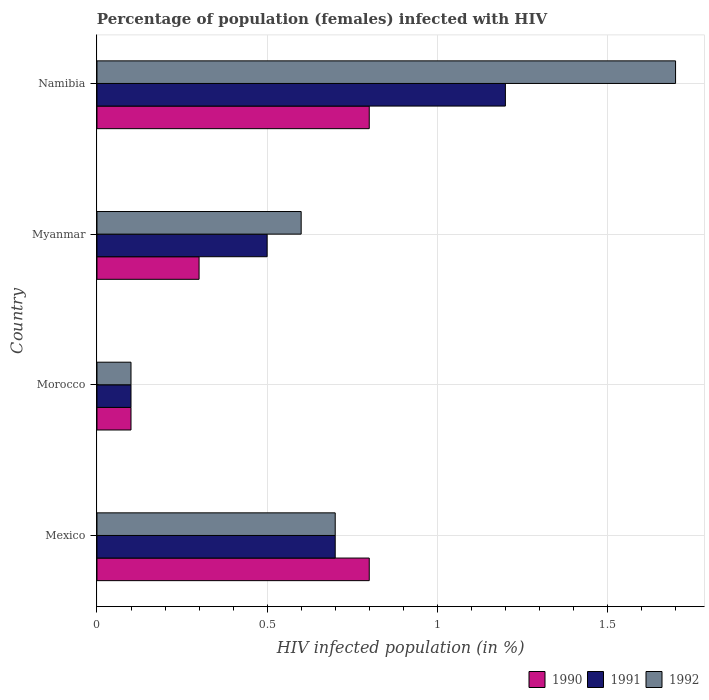Are the number of bars per tick equal to the number of legend labels?
Your answer should be very brief. Yes. What is the label of the 2nd group of bars from the top?
Offer a very short reply. Myanmar. What is the percentage of HIV infected female population in 1992 in Mexico?
Offer a terse response. 0.7. Across all countries, what is the maximum percentage of HIV infected female population in 1992?
Offer a terse response. 1.7. In which country was the percentage of HIV infected female population in 1991 maximum?
Your answer should be compact. Namibia. In which country was the percentage of HIV infected female population in 1991 minimum?
Ensure brevity in your answer.  Morocco. What is the difference between the percentage of HIV infected female population in 1992 in Myanmar and the percentage of HIV infected female population in 1991 in Namibia?
Offer a terse response. -0.6. What is the average percentage of HIV infected female population in 1992 per country?
Provide a succinct answer. 0.77. What is the ratio of the percentage of HIV infected female population in 1990 in Myanmar to that in Namibia?
Your answer should be very brief. 0.37. What is the difference between the highest and the lowest percentage of HIV infected female population in 1990?
Offer a terse response. 0.7. What does the 2nd bar from the bottom in Morocco represents?
Your answer should be compact. 1991. How many countries are there in the graph?
Your answer should be very brief. 4. Does the graph contain grids?
Give a very brief answer. Yes. What is the title of the graph?
Your response must be concise. Percentage of population (females) infected with HIV. Does "2010" appear as one of the legend labels in the graph?
Make the answer very short. No. What is the label or title of the X-axis?
Offer a terse response. HIV infected population (in %). What is the label or title of the Y-axis?
Your answer should be compact. Country. What is the HIV infected population (in %) in 1990 in Mexico?
Give a very brief answer. 0.8. What is the HIV infected population (in %) of 1991 in Mexico?
Make the answer very short. 0.7. What is the HIV infected population (in %) in 1990 in Morocco?
Ensure brevity in your answer.  0.1. What is the HIV infected population (in %) of 1992 in Myanmar?
Ensure brevity in your answer.  0.6. What is the HIV infected population (in %) in 1990 in Namibia?
Your answer should be compact. 0.8. What is the HIV infected population (in %) in 1991 in Namibia?
Offer a very short reply. 1.2. Across all countries, what is the maximum HIV infected population (in %) of 1992?
Offer a very short reply. 1.7. Across all countries, what is the minimum HIV infected population (in %) of 1990?
Ensure brevity in your answer.  0.1. Across all countries, what is the minimum HIV infected population (in %) in 1992?
Ensure brevity in your answer.  0.1. What is the total HIV infected population (in %) in 1990 in the graph?
Provide a succinct answer. 2. What is the total HIV infected population (in %) of 1991 in the graph?
Ensure brevity in your answer.  2.5. What is the total HIV infected population (in %) in 1992 in the graph?
Your response must be concise. 3.1. What is the difference between the HIV infected population (in %) of 1990 in Mexico and that in Morocco?
Keep it short and to the point. 0.7. What is the difference between the HIV infected population (in %) of 1990 in Mexico and that in Myanmar?
Your response must be concise. 0.5. What is the difference between the HIV infected population (in %) in 1991 in Mexico and that in Myanmar?
Ensure brevity in your answer.  0.2. What is the difference between the HIV infected population (in %) of 1992 in Mexico and that in Myanmar?
Your answer should be very brief. 0.1. What is the difference between the HIV infected population (in %) in 1991 in Mexico and that in Namibia?
Your answer should be compact. -0.5. What is the difference between the HIV infected population (in %) of 1992 in Morocco and that in Myanmar?
Your answer should be compact. -0.5. What is the difference between the HIV infected population (in %) in 1990 in Morocco and that in Namibia?
Offer a terse response. -0.7. What is the difference between the HIV infected population (in %) in 1990 in Mexico and the HIV infected population (in %) in 1991 in Myanmar?
Offer a very short reply. 0.3. What is the difference between the HIV infected population (in %) of 1990 in Mexico and the HIV infected population (in %) of 1992 in Myanmar?
Offer a very short reply. 0.2. What is the difference between the HIV infected population (in %) of 1991 in Mexico and the HIV infected population (in %) of 1992 in Myanmar?
Your answer should be very brief. 0.1. What is the difference between the HIV infected population (in %) in 1990 in Mexico and the HIV infected population (in %) in 1991 in Namibia?
Offer a terse response. -0.4. What is the difference between the HIV infected population (in %) in 1991 in Mexico and the HIV infected population (in %) in 1992 in Namibia?
Offer a terse response. -1. What is the difference between the HIV infected population (in %) of 1990 in Morocco and the HIV infected population (in %) of 1992 in Myanmar?
Provide a succinct answer. -0.5. What is the difference between the HIV infected population (in %) in 1991 in Morocco and the HIV infected population (in %) in 1992 in Myanmar?
Provide a succinct answer. -0.5. What is the difference between the HIV infected population (in %) of 1991 in Morocco and the HIV infected population (in %) of 1992 in Namibia?
Ensure brevity in your answer.  -1.6. What is the average HIV infected population (in %) of 1990 per country?
Provide a short and direct response. 0.5. What is the average HIV infected population (in %) in 1991 per country?
Provide a short and direct response. 0.62. What is the average HIV infected population (in %) of 1992 per country?
Make the answer very short. 0.78. What is the difference between the HIV infected population (in %) in 1991 and HIV infected population (in %) in 1992 in Mexico?
Offer a very short reply. 0. What is the difference between the HIV infected population (in %) in 1990 and HIV infected population (in %) in 1991 in Morocco?
Make the answer very short. 0. What is the difference between the HIV infected population (in %) of 1990 and HIV infected population (in %) of 1992 in Morocco?
Provide a short and direct response. 0. What is the difference between the HIV infected population (in %) in 1990 and HIV infected population (in %) in 1991 in Myanmar?
Ensure brevity in your answer.  -0.2. What is the difference between the HIV infected population (in %) of 1990 and HIV infected population (in %) of 1991 in Namibia?
Provide a succinct answer. -0.4. What is the difference between the HIV infected population (in %) in 1990 and HIV infected population (in %) in 1992 in Namibia?
Give a very brief answer. -0.9. What is the difference between the HIV infected population (in %) in 1991 and HIV infected population (in %) in 1992 in Namibia?
Give a very brief answer. -0.5. What is the ratio of the HIV infected population (in %) in 1991 in Mexico to that in Morocco?
Your answer should be compact. 7. What is the ratio of the HIV infected population (in %) in 1992 in Mexico to that in Morocco?
Ensure brevity in your answer.  7. What is the ratio of the HIV infected population (in %) in 1990 in Mexico to that in Myanmar?
Give a very brief answer. 2.67. What is the ratio of the HIV infected population (in %) of 1991 in Mexico to that in Myanmar?
Your response must be concise. 1.4. What is the ratio of the HIV infected population (in %) in 1990 in Mexico to that in Namibia?
Offer a very short reply. 1. What is the ratio of the HIV infected population (in %) of 1991 in Mexico to that in Namibia?
Offer a terse response. 0.58. What is the ratio of the HIV infected population (in %) in 1992 in Mexico to that in Namibia?
Provide a short and direct response. 0.41. What is the ratio of the HIV infected population (in %) in 1990 in Morocco to that in Myanmar?
Keep it short and to the point. 0.33. What is the ratio of the HIV infected population (in %) in 1992 in Morocco to that in Myanmar?
Your answer should be compact. 0.17. What is the ratio of the HIV infected population (in %) in 1990 in Morocco to that in Namibia?
Offer a very short reply. 0.12. What is the ratio of the HIV infected population (in %) of 1991 in Morocco to that in Namibia?
Give a very brief answer. 0.08. What is the ratio of the HIV infected population (in %) of 1992 in Morocco to that in Namibia?
Provide a short and direct response. 0.06. What is the ratio of the HIV infected population (in %) in 1991 in Myanmar to that in Namibia?
Ensure brevity in your answer.  0.42. What is the ratio of the HIV infected population (in %) in 1992 in Myanmar to that in Namibia?
Keep it short and to the point. 0.35. What is the difference between the highest and the second highest HIV infected population (in %) of 1991?
Your response must be concise. 0.5. What is the difference between the highest and the second highest HIV infected population (in %) of 1992?
Ensure brevity in your answer.  1. What is the difference between the highest and the lowest HIV infected population (in %) in 1990?
Offer a terse response. 0.7. What is the difference between the highest and the lowest HIV infected population (in %) of 1991?
Make the answer very short. 1.1. What is the difference between the highest and the lowest HIV infected population (in %) in 1992?
Your answer should be very brief. 1.6. 